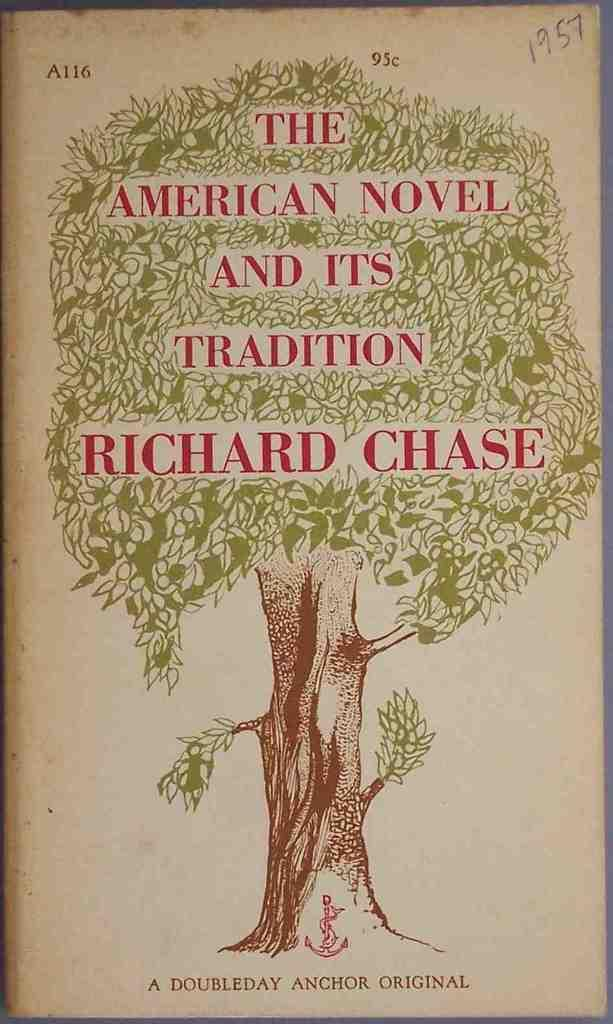Provide a one-sentence caption for the provided image. A book with a tree on it called American Novel and its tradition by Richard Chase. 